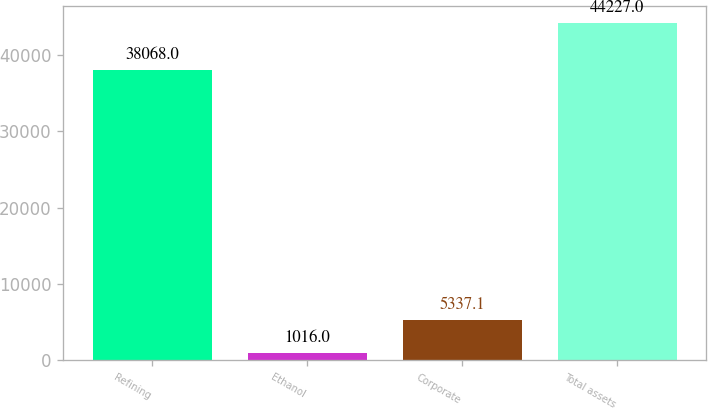Convert chart. <chart><loc_0><loc_0><loc_500><loc_500><bar_chart><fcel>Refining<fcel>Ethanol<fcel>Corporate<fcel>Total assets<nl><fcel>38068<fcel>1016<fcel>5337.1<fcel>44227<nl></chart> 